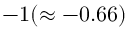<formula> <loc_0><loc_0><loc_500><loc_500>- 1 ( \approx - 0 . 6 6 )</formula> 